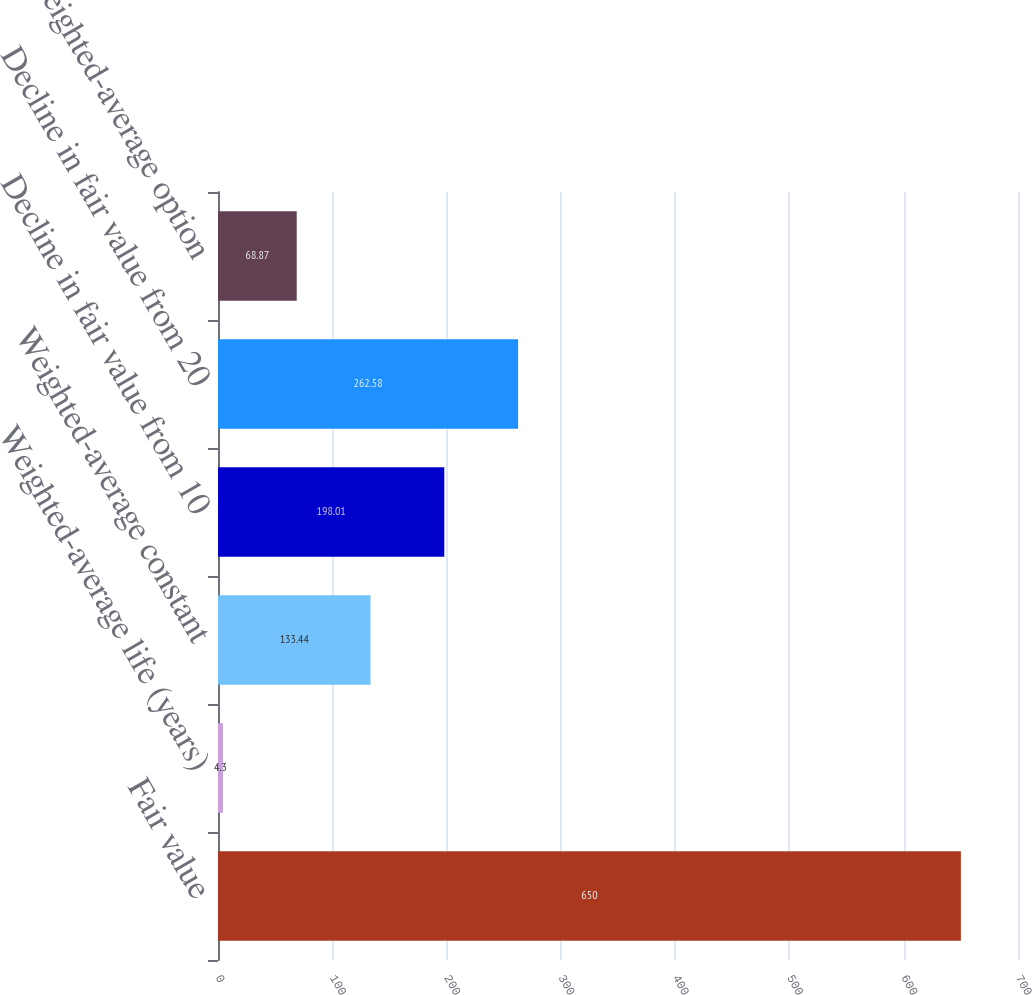<chart> <loc_0><loc_0><loc_500><loc_500><bar_chart><fcel>Fair value<fcel>Weighted-average life (years)<fcel>Weighted-average constant<fcel>Decline in fair value from 10<fcel>Decline in fair value from 20<fcel>Weighted-average option<nl><fcel>650<fcel>4.3<fcel>133.44<fcel>198.01<fcel>262.58<fcel>68.87<nl></chart> 